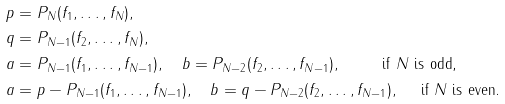<formula> <loc_0><loc_0><loc_500><loc_500>p & = P _ { N } ( f _ { 1 } , \dots , f _ { N } ) , \\ q & = P _ { N - 1 } ( f _ { 2 } , \dots , f _ { N } ) , \\ a & = P _ { N - 1 } ( f _ { 1 } , \dots , f _ { N - 1 } ) , \quad b = P _ { N - 2 } ( f _ { 2 } , \dots , f _ { N - 1 } ) , \quad \, \quad \text { if $N$ is odd,} \\ a & = p - P _ { N - 1 } ( f _ { 1 } , \dots , f _ { N - 1 } ) , \quad b = q - P _ { N - 2 } ( f _ { 2 } , \dots , f _ { N - 1 } ) , \quad \text { if $N$ is even.}</formula> 